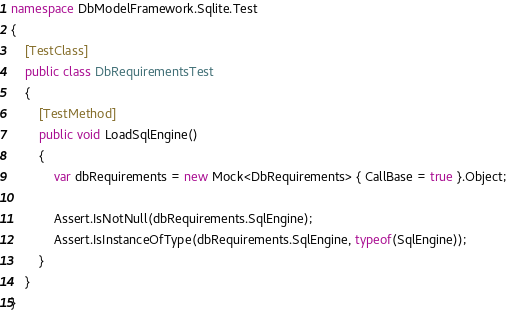<code> <loc_0><loc_0><loc_500><loc_500><_C#_>namespace DbModelFramework.Sqlite.Test
{
	[TestClass]
	public class DbRequirementsTest
	{
		[TestMethod]
		public void LoadSqlEngine()
		{
			var dbRequirements = new Mock<DbRequirements> { CallBase = true }.Object;

			Assert.IsNotNull(dbRequirements.SqlEngine);
			Assert.IsInstanceOfType(dbRequirements.SqlEngine, typeof(SqlEngine));
		}
	}
}
</code> 